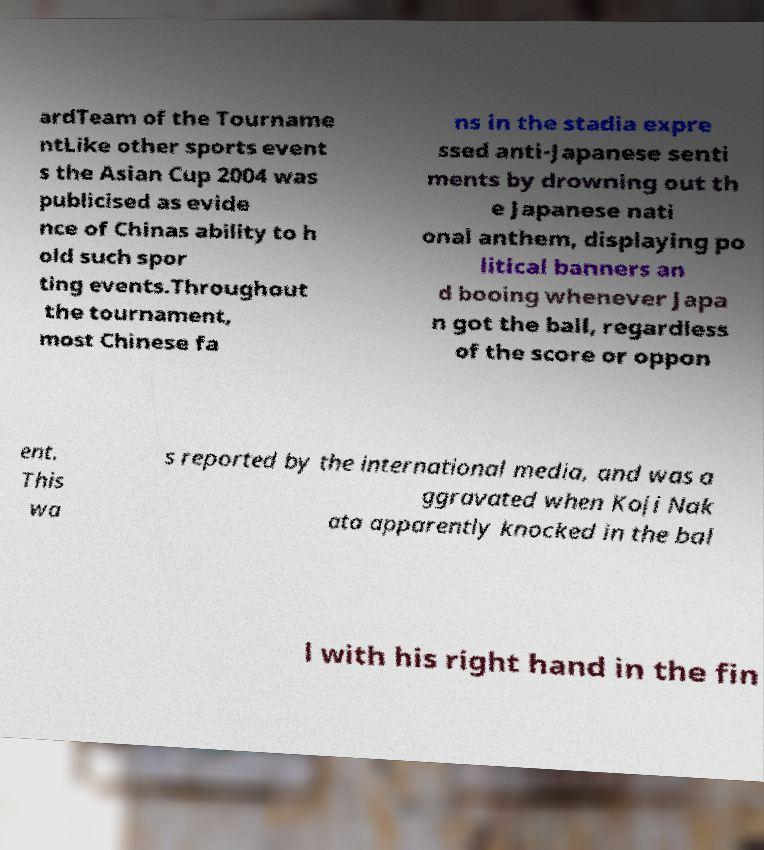Can you read and provide the text displayed in the image?This photo seems to have some interesting text. Can you extract and type it out for me? ardTeam of the Tourname ntLike other sports event s the Asian Cup 2004 was publicised as evide nce of Chinas ability to h old such spor ting events.Throughout the tournament, most Chinese fa ns in the stadia expre ssed anti-Japanese senti ments by drowning out th e Japanese nati onal anthem, displaying po litical banners an d booing whenever Japa n got the ball, regardless of the score or oppon ent. This wa s reported by the international media, and was a ggravated when Koji Nak ata apparently knocked in the bal l with his right hand in the fin 